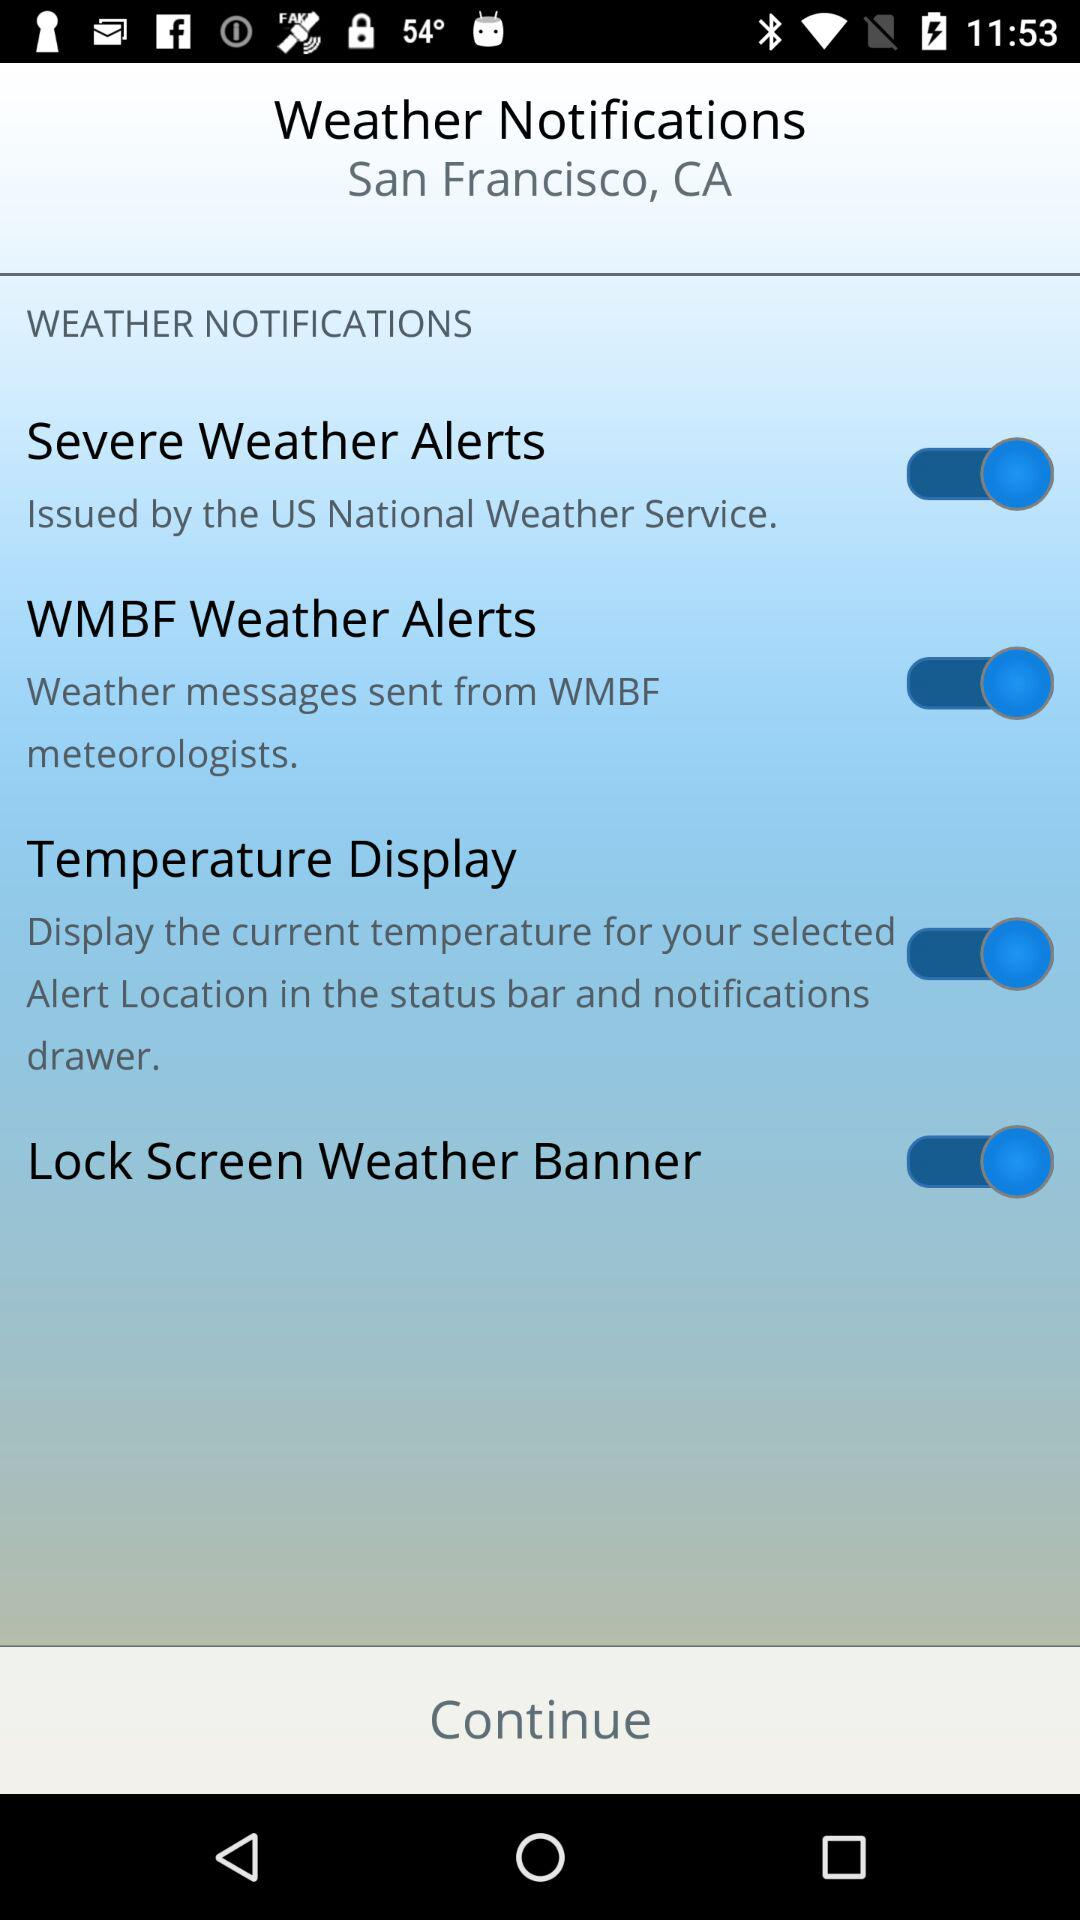What is the status of "Severe Weather Alerts"? The status is "on". 